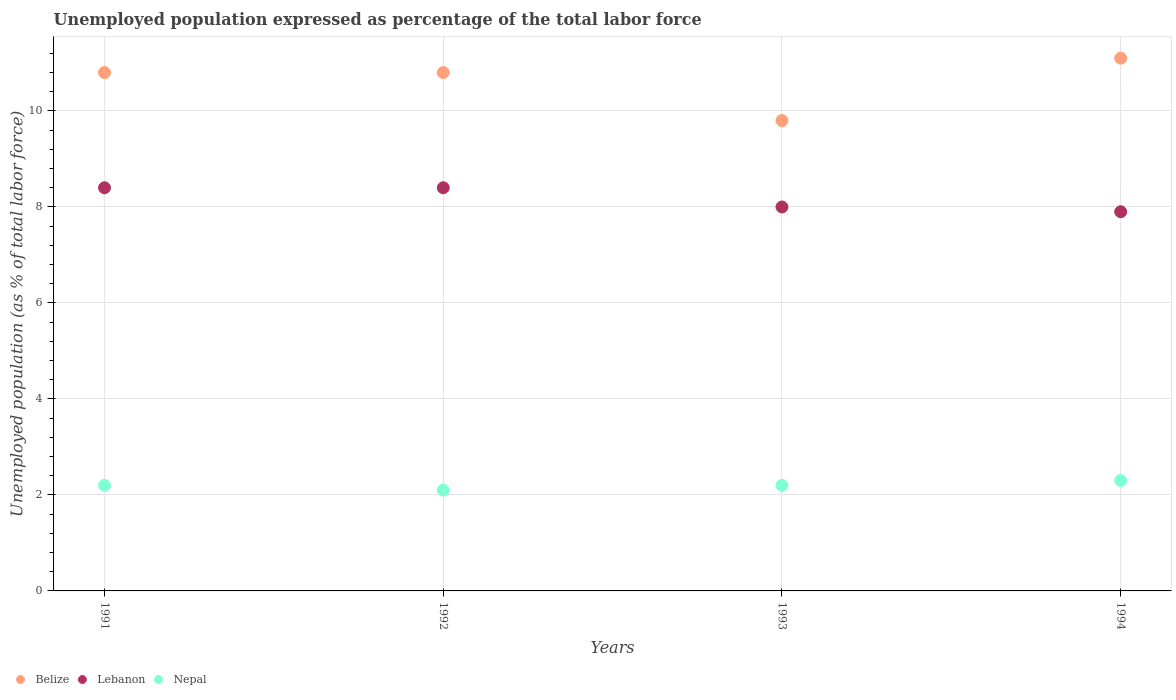What is the unemployment in in Lebanon in 1994?
Provide a succinct answer. 7.9. Across all years, what is the maximum unemployment in in Nepal?
Provide a succinct answer. 2.3. Across all years, what is the minimum unemployment in in Nepal?
Offer a very short reply. 2.1. In which year was the unemployment in in Nepal maximum?
Offer a terse response. 1994. In which year was the unemployment in in Lebanon minimum?
Your answer should be compact. 1994. What is the total unemployment in in Lebanon in the graph?
Keep it short and to the point. 32.7. What is the difference between the unemployment in in Nepal in 1991 and the unemployment in in Lebanon in 1992?
Give a very brief answer. -6.2. What is the average unemployment in in Belize per year?
Your response must be concise. 10.63. In the year 1993, what is the difference between the unemployment in in Nepal and unemployment in in Lebanon?
Make the answer very short. -5.8. In how many years, is the unemployment in in Belize greater than 10 %?
Give a very brief answer. 3. What is the ratio of the unemployment in in Belize in 1992 to that in 1993?
Provide a succinct answer. 1.1. What is the difference between the highest and the second highest unemployment in in Lebanon?
Your response must be concise. 0. What is the difference between the highest and the lowest unemployment in in Nepal?
Make the answer very short. 0.2. In how many years, is the unemployment in in Lebanon greater than the average unemployment in in Lebanon taken over all years?
Keep it short and to the point. 2. Is it the case that in every year, the sum of the unemployment in in Belize and unemployment in in Nepal  is greater than the unemployment in in Lebanon?
Provide a short and direct response. Yes. Does the unemployment in in Lebanon monotonically increase over the years?
Your answer should be very brief. No. Is the unemployment in in Nepal strictly greater than the unemployment in in Lebanon over the years?
Ensure brevity in your answer.  No. Is the unemployment in in Lebanon strictly less than the unemployment in in Belize over the years?
Offer a terse response. Yes. How many dotlines are there?
Make the answer very short. 3. Does the graph contain any zero values?
Offer a terse response. No. Does the graph contain grids?
Offer a terse response. Yes. How many legend labels are there?
Provide a succinct answer. 3. How are the legend labels stacked?
Ensure brevity in your answer.  Horizontal. What is the title of the graph?
Offer a very short reply. Unemployed population expressed as percentage of the total labor force. What is the label or title of the Y-axis?
Offer a very short reply. Unemployed population (as % of total labor force). What is the Unemployed population (as % of total labor force) in Belize in 1991?
Your response must be concise. 10.8. What is the Unemployed population (as % of total labor force) of Lebanon in 1991?
Make the answer very short. 8.4. What is the Unemployed population (as % of total labor force) in Nepal in 1991?
Ensure brevity in your answer.  2.2. What is the Unemployed population (as % of total labor force) in Belize in 1992?
Ensure brevity in your answer.  10.8. What is the Unemployed population (as % of total labor force) of Lebanon in 1992?
Provide a short and direct response. 8.4. What is the Unemployed population (as % of total labor force) of Nepal in 1992?
Give a very brief answer. 2.1. What is the Unemployed population (as % of total labor force) in Belize in 1993?
Offer a very short reply. 9.8. What is the Unemployed population (as % of total labor force) of Lebanon in 1993?
Offer a terse response. 8. What is the Unemployed population (as % of total labor force) in Nepal in 1993?
Your response must be concise. 2.2. What is the Unemployed population (as % of total labor force) in Belize in 1994?
Provide a succinct answer. 11.1. What is the Unemployed population (as % of total labor force) of Lebanon in 1994?
Provide a short and direct response. 7.9. What is the Unemployed population (as % of total labor force) in Nepal in 1994?
Make the answer very short. 2.3. Across all years, what is the maximum Unemployed population (as % of total labor force) of Belize?
Your answer should be very brief. 11.1. Across all years, what is the maximum Unemployed population (as % of total labor force) of Lebanon?
Ensure brevity in your answer.  8.4. Across all years, what is the maximum Unemployed population (as % of total labor force) in Nepal?
Provide a short and direct response. 2.3. Across all years, what is the minimum Unemployed population (as % of total labor force) in Belize?
Offer a terse response. 9.8. Across all years, what is the minimum Unemployed population (as % of total labor force) of Lebanon?
Offer a very short reply. 7.9. Across all years, what is the minimum Unemployed population (as % of total labor force) in Nepal?
Make the answer very short. 2.1. What is the total Unemployed population (as % of total labor force) of Belize in the graph?
Make the answer very short. 42.5. What is the total Unemployed population (as % of total labor force) of Lebanon in the graph?
Give a very brief answer. 32.7. What is the total Unemployed population (as % of total labor force) of Nepal in the graph?
Provide a succinct answer. 8.8. What is the difference between the Unemployed population (as % of total labor force) of Lebanon in 1991 and that in 1992?
Your answer should be very brief. 0. What is the difference between the Unemployed population (as % of total labor force) in Nepal in 1991 and that in 1992?
Offer a very short reply. 0.1. What is the difference between the Unemployed population (as % of total labor force) in Belize in 1991 and that in 1993?
Offer a terse response. 1. What is the difference between the Unemployed population (as % of total labor force) in Nepal in 1991 and that in 1993?
Your answer should be very brief. 0. What is the difference between the Unemployed population (as % of total labor force) of Belize in 1991 and that in 1994?
Provide a short and direct response. -0.3. What is the difference between the Unemployed population (as % of total labor force) in Lebanon in 1991 and that in 1994?
Make the answer very short. 0.5. What is the difference between the Unemployed population (as % of total labor force) in Nepal in 1991 and that in 1994?
Keep it short and to the point. -0.1. What is the difference between the Unemployed population (as % of total labor force) in Belize in 1992 and that in 1994?
Give a very brief answer. -0.3. What is the difference between the Unemployed population (as % of total labor force) of Lebanon in 1992 and that in 1994?
Offer a terse response. 0.5. What is the difference between the Unemployed population (as % of total labor force) of Nepal in 1992 and that in 1994?
Offer a very short reply. -0.2. What is the difference between the Unemployed population (as % of total labor force) of Belize in 1993 and that in 1994?
Your answer should be compact. -1.3. What is the difference between the Unemployed population (as % of total labor force) of Nepal in 1993 and that in 1994?
Offer a very short reply. -0.1. What is the difference between the Unemployed population (as % of total labor force) of Belize in 1991 and the Unemployed population (as % of total labor force) of Lebanon in 1992?
Ensure brevity in your answer.  2.4. What is the difference between the Unemployed population (as % of total labor force) of Belize in 1991 and the Unemployed population (as % of total labor force) of Nepal in 1992?
Your response must be concise. 8.7. What is the difference between the Unemployed population (as % of total labor force) in Belize in 1991 and the Unemployed population (as % of total labor force) in Nepal in 1993?
Ensure brevity in your answer.  8.6. What is the difference between the Unemployed population (as % of total labor force) of Lebanon in 1991 and the Unemployed population (as % of total labor force) of Nepal in 1993?
Your response must be concise. 6.2. What is the difference between the Unemployed population (as % of total labor force) of Lebanon in 1991 and the Unemployed population (as % of total labor force) of Nepal in 1994?
Offer a very short reply. 6.1. What is the difference between the Unemployed population (as % of total labor force) of Belize in 1992 and the Unemployed population (as % of total labor force) of Lebanon in 1993?
Your response must be concise. 2.8. What is the difference between the Unemployed population (as % of total labor force) of Belize in 1992 and the Unemployed population (as % of total labor force) of Nepal in 1993?
Your answer should be very brief. 8.6. What is the difference between the Unemployed population (as % of total labor force) of Lebanon in 1992 and the Unemployed population (as % of total labor force) of Nepal in 1993?
Offer a very short reply. 6.2. What is the difference between the Unemployed population (as % of total labor force) of Belize in 1992 and the Unemployed population (as % of total labor force) of Lebanon in 1994?
Ensure brevity in your answer.  2.9. What is the difference between the Unemployed population (as % of total labor force) of Belize in 1992 and the Unemployed population (as % of total labor force) of Nepal in 1994?
Keep it short and to the point. 8.5. What is the difference between the Unemployed population (as % of total labor force) of Belize in 1993 and the Unemployed population (as % of total labor force) of Nepal in 1994?
Provide a short and direct response. 7.5. What is the average Unemployed population (as % of total labor force) in Belize per year?
Provide a short and direct response. 10.62. What is the average Unemployed population (as % of total labor force) in Lebanon per year?
Offer a terse response. 8.18. What is the average Unemployed population (as % of total labor force) of Nepal per year?
Ensure brevity in your answer.  2.2. In the year 1991, what is the difference between the Unemployed population (as % of total labor force) of Belize and Unemployed population (as % of total labor force) of Lebanon?
Provide a succinct answer. 2.4. In the year 1992, what is the difference between the Unemployed population (as % of total labor force) of Belize and Unemployed population (as % of total labor force) of Lebanon?
Keep it short and to the point. 2.4. In the year 1992, what is the difference between the Unemployed population (as % of total labor force) of Belize and Unemployed population (as % of total labor force) of Nepal?
Give a very brief answer. 8.7. In the year 1993, what is the difference between the Unemployed population (as % of total labor force) of Belize and Unemployed population (as % of total labor force) of Lebanon?
Provide a succinct answer. 1.8. In the year 1994, what is the difference between the Unemployed population (as % of total labor force) of Belize and Unemployed population (as % of total labor force) of Lebanon?
Your answer should be very brief. 3.2. In the year 1994, what is the difference between the Unemployed population (as % of total labor force) of Belize and Unemployed population (as % of total labor force) of Nepal?
Provide a succinct answer. 8.8. In the year 1994, what is the difference between the Unemployed population (as % of total labor force) in Lebanon and Unemployed population (as % of total labor force) in Nepal?
Your response must be concise. 5.6. What is the ratio of the Unemployed population (as % of total labor force) in Nepal in 1991 to that in 1992?
Your response must be concise. 1.05. What is the ratio of the Unemployed population (as % of total labor force) of Belize in 1991 to that in 1993?
Give a very brief answer. 1.1. What is the ratio of the Unemployed population (as % of total labor force) in Lebanon in 1991 to that in 1993?
Offer a very short reply. 1.05. What is the ratio of the Unemployed population (as % of total labor force) in Belize in 1991 to that in 1994?
Provide a succinct answer. 0.97. What is the ratio of the Unemployed population (as % of total labor force) of Lebanon in 1991 to that in 1994?
Provide a succinct answer. 1.06. What is the ratio of the Unemployed population (as % of total labor force) in Nepal in 1991 to that in 1994?
Your answer should be compact. 0.96. What is the ratio of the Unemployed population (as % of total labor force) of Belize in 1992 to that in 1993?
Offer a very short reply. 1.1. What is the ratio of the Unemployed population (as % of total labor force) of Nepal in 1992 to that in 1993?
Make the answer very short. 0.95. What is the ratio of the Unemployed population (as % of total labor force) of Lebanon in 1992 to that in 1994?
Provide a short and direct response. 1.06. What is the ratio of the Unemployed population (as % of total labor force) of Belize in 1993 to that in 1994?
Offer a terse response. 0.88. What is the ratio of the Unemployed population (as % of total labor force) in Lebanon in 1993 to that in 1994?
Make the answer very short. 1.01. What is the ratio of the Unemployed population (as % of total labor force) of Nepal in 1993 to that in 1994?
Offer a terse response. 0.96. What is the difference between the highest and the second highest Unemployed population (as % of total labor force) in Lebanon?
Ensure brevity in your answer.  0. What is the difference between the highest and the second highest Unemployed population (as % of total labor force) of Nepal?
Ensure brevity in your answer.  0.1. 